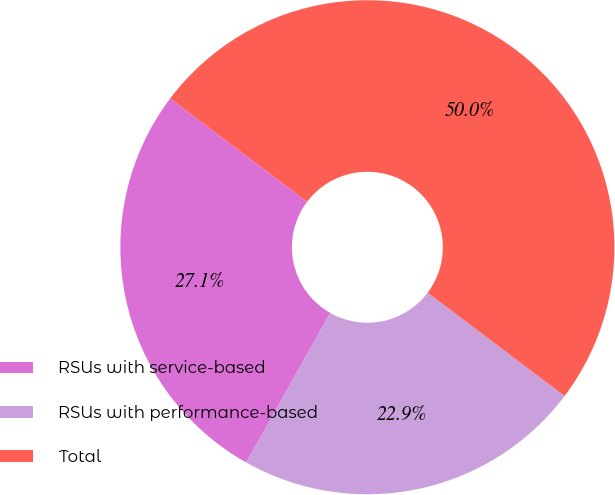Convert chart. <chart><loc_0><loc_0><loc_500><loc_500><pie_chart><fcel>RSUs with service-based<fcel>RSUs with performance-based<fcel>Total<nl><fcel>27.13%<fcel>22.87%<fcel>50.0%<nl></chart> 